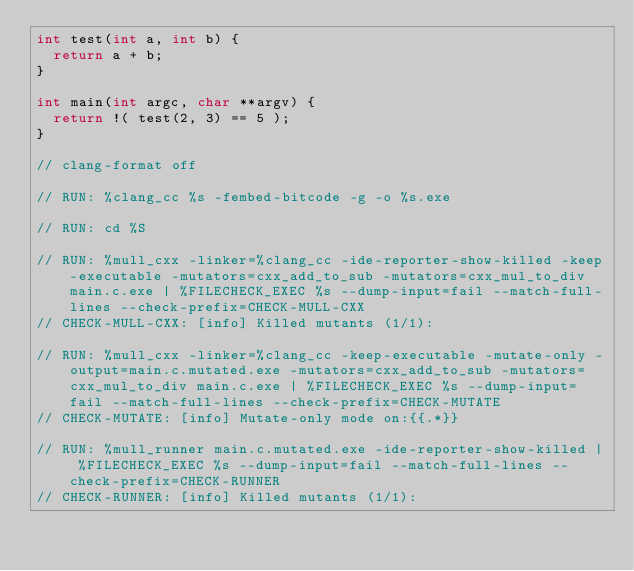Convert code to text. <code><loc_0><loc_0><loc_500><loc_500><_C_>int test(int a, int b) {
  return a + b;
}

int main(int argc, char **argv) {
  return !( test(2, 3) == 5 );
}

// clang-format off

// RUN: %clang_cc %s -fembed-bitcode -g -o %s.exe

// RUN: cd %S

// RUN: %mull_cxx -linker=%clang_cc -ide-reporter-show-killed -keep-executable -mutators=cxx_add_to_sub -mutators=cxx_mul_to_div main.c.exe | %FILECHECK_EXEC %s --dump-input=fail --match-full-lines --check-prefix=CHECK-MULL-CXX
// CHECK-MULL-CXX: [info] Killed mutants (1/1):

// RUN: %mull_cxx -linker=%clang_cc -keep-executable -mutate-only -output=main.c.mutated.exe -mutators=cxx_add_to_sub -mutators=cxx_mul_to_div main.c.exe | %FILECHECK_EXEC %s --dump-input=fail --match-full-lines --check-prefix=CHECK-MUTATE
// CHECK-MUTATE: [info] Mutate-only mode on:{{.*}}

// RUN: %mull_runner main.c.mutated.exe -ide-reporter-show-killed | %FILECHECK_EXEC %s --dump-input=fail --match-full-lines --check-prefix=CHECK-RUNNER
// CHECK-RUNNER: [info] Killed mutants (1/1):
</code> 